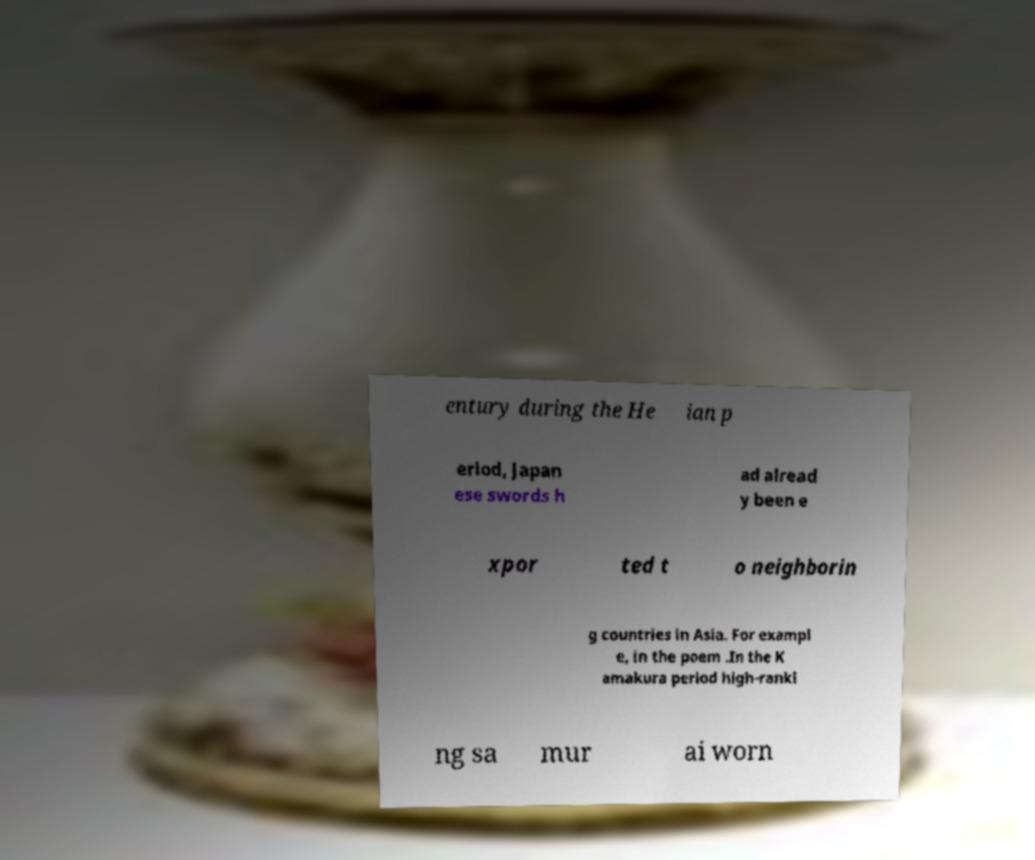Can you accurately transcribe the text from the provided image for me? entury during the He ian p eriod, Japan ese swords h ad alread y been e xpor ted t o neighborin g countries in Asia. For exampl e, in the poem .In the K amakura period high-ranki ng sa mur ai worn 